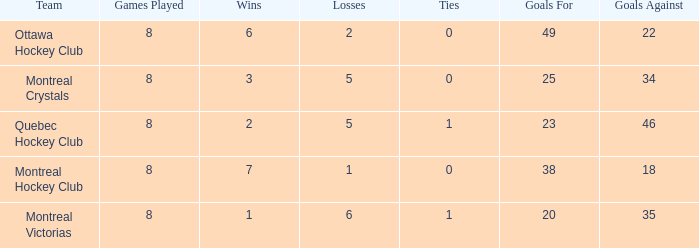What is the average losses when the wins is 3? 5.0. 